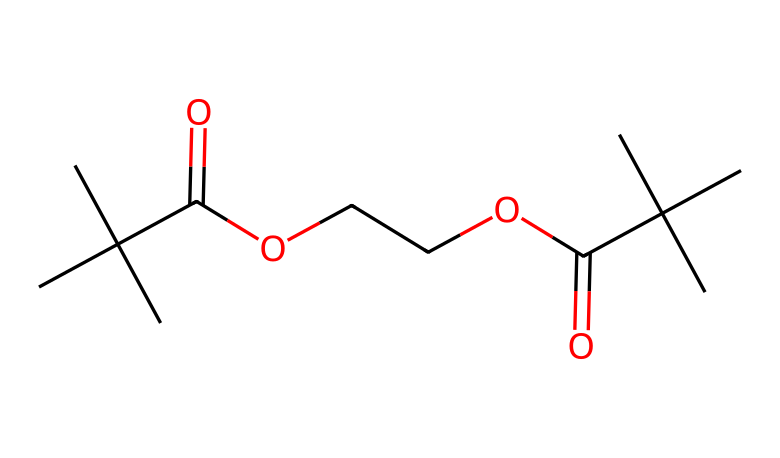What is the main functional group present in this chemical? The functional group present in the SMILES is represented by the "C(=O)O" and "C(=O)" portions, indicating the existence of carboxylic acid and ester groups.
Answer: carboxylic acid and ester How many carbon atoms are in this chemical structure? By analyzing the SMILES representation, we count a total of 9 carbon (C) atoms as each 'C' in the string represents one carbon atom.
Answer: 9 What type of solvent can effectively dissolve this photoresist? Since the chemical is water-soluble, it indicates that water is an effective solvent for this photoresist, as the water-soluble characteristics are implied by the functional groups present.
Answer: water What is the expected environmental impact of using this photoresist? Given that the photoresist is described as environmentally friendly and water-soluble, it suggests minimal toxicity and a lower environmental impact compared to traditional solvents, which often contain harmful chemicals.
Answer: minimal toxicity How many ester functional groups are present in this photoresist? The presence of ester functional groups can be identified as there are two "C(=O)O" sets observed in the SMILES representation, which correspond to two ester groups.
Answer: 2 What is the significance of water solubility for construction site markings? Water solubility allows for easy application and removal of the markings, ensures that they do not persist in the environment, and facilitates safety in construction areas where temporary markings are essential.
Answer: easy application and removal 